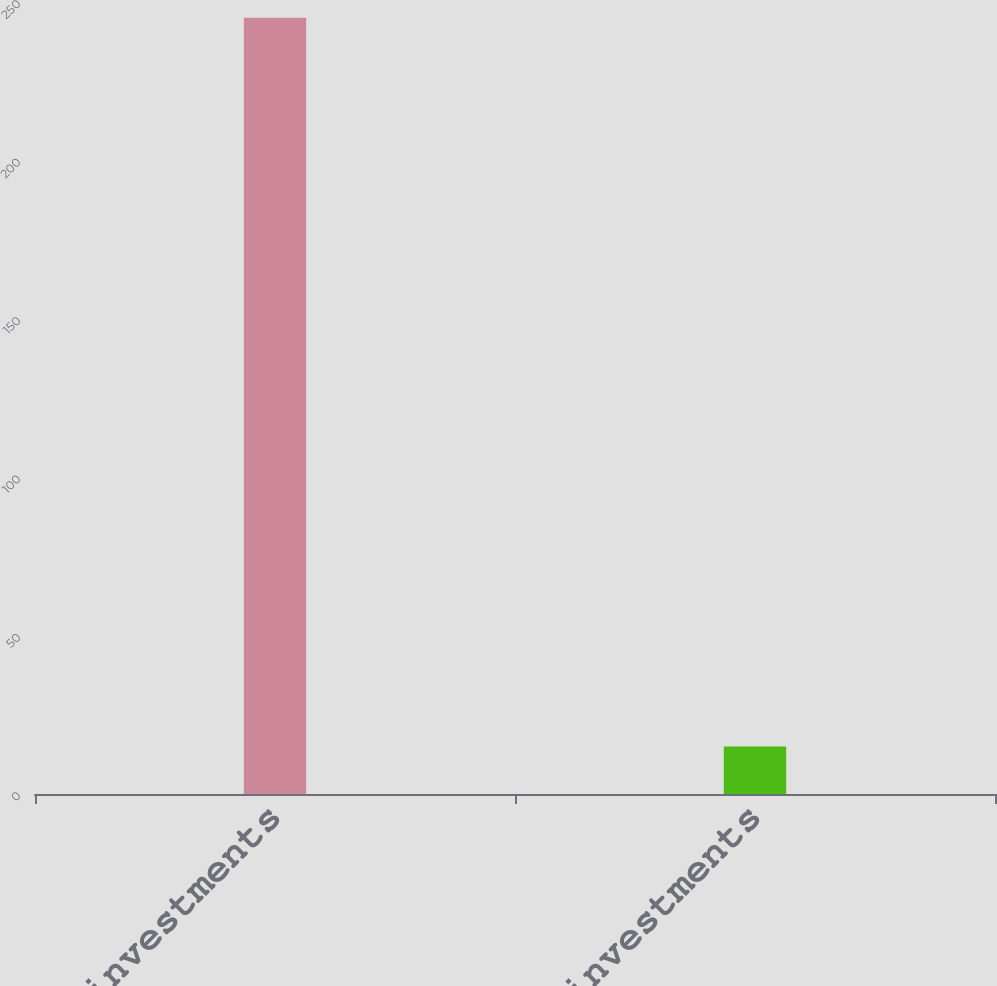<chart> <loc_0><loc_0><loc_500><loc_500><bar_chart><fcel>Equity investments<fcel>Other investments<nl><fcel>245<fcel>15<nl></chart> 